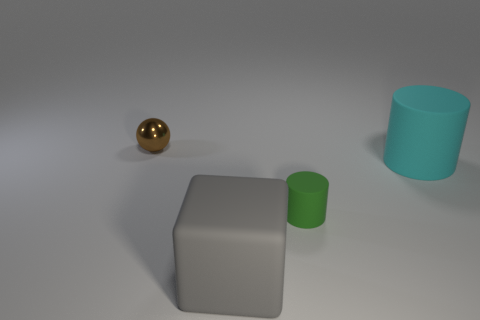Is the number of large matte cylinders behind the gray matte object greater than the number of cyan cylinders that are left of the small rubber cylinder?
Offer a very short reply. Yes. How many spheres are either blue shiny objects or large rubber objects?
Keep it short and to the point. 0. There is a cylinder on the left side of the large matte thing to the right of the big gray object; what number of cyan matte cylinders are behind it?
Offer a very short reply. 1. Are there more gray matte spheres than cyan cylinders?
Give a very brief answer. No. Do the green rubber cylinder and the brown metal object have the same size?
Your answer should be very brief. Yes. What number of objects are spheres or small green matte objects?
Your answer should be compact. 2. There is a big thing behind the large matte thing that is left of the big matte object that is on the right side of the gray matte thing; what shape is it?
Offer a very short reply. Cylinder. Is the large thing that is behind the big matte cube made of the same material as the large thing in front of the large cyan thing?
Your answer should be very brief. Yes. There is another tiny object that is the same shape as the cyan object; what is it made of?
Ensure brevity in your answer.  Rubber. Does the big thing on the right side of the big gray cube have the same shape as the tiny thing on the right side of the gray block?
Your response must be concise. Yes. 